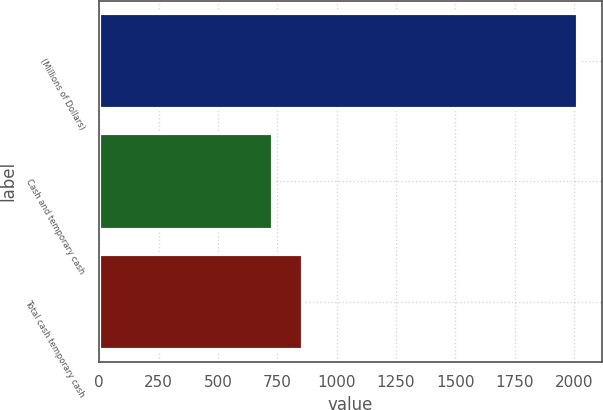<chart> <loc_0><loc_0><loc_500><loc_500><bar_chart><fcel>(Millions of Dollars)<fcel>Cash and temporary cash<fcel>Total cash temporary cash<nl><fcel>2017<fcel>730<fcel>858.7<nl></chart> 